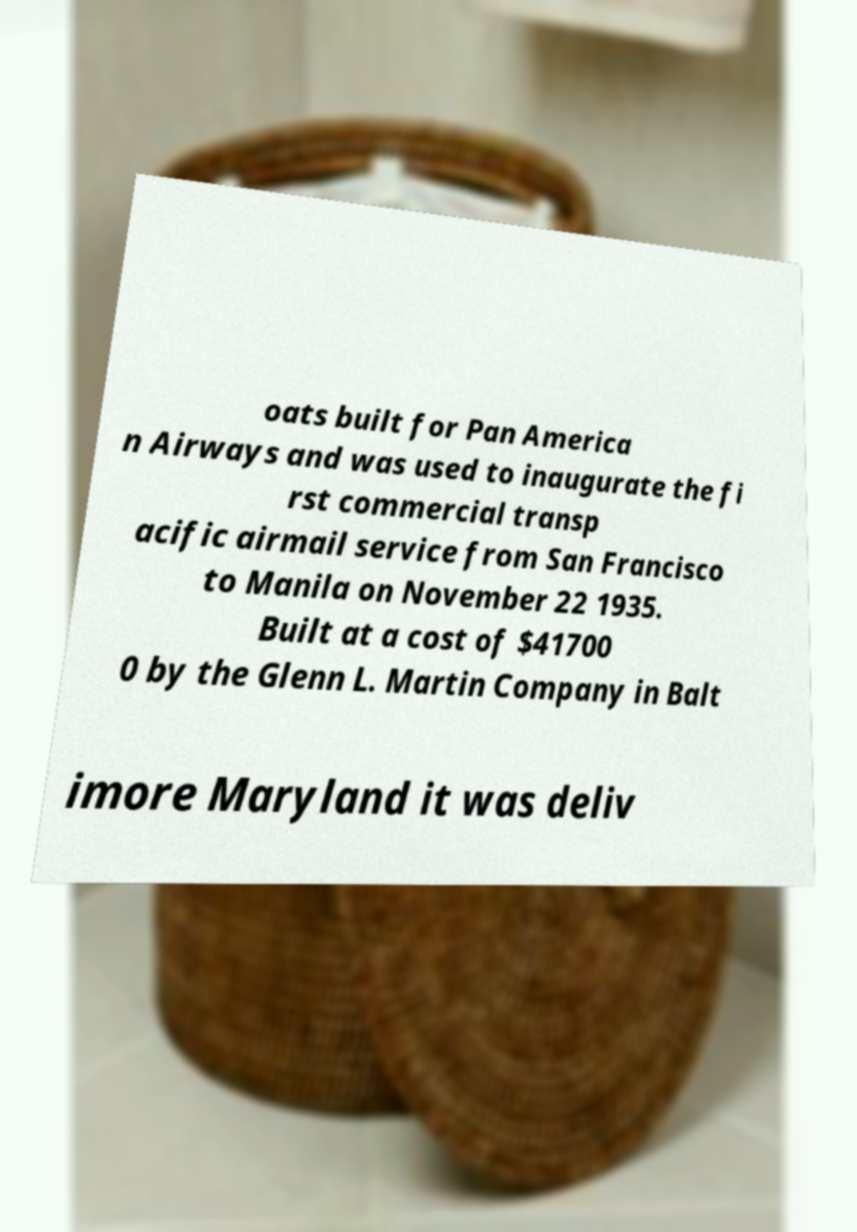I need the written content from this picture converted into text. Can you do that? oats built for Pan America n Airways and was used to inaugurate the fi rst commercial transp acific airmail service from San Francisco to Manila on November 22 1935. Built at a cost of $41700 0 by the Glenn L. Martin Company in Balt imore Maryland it was deliv 